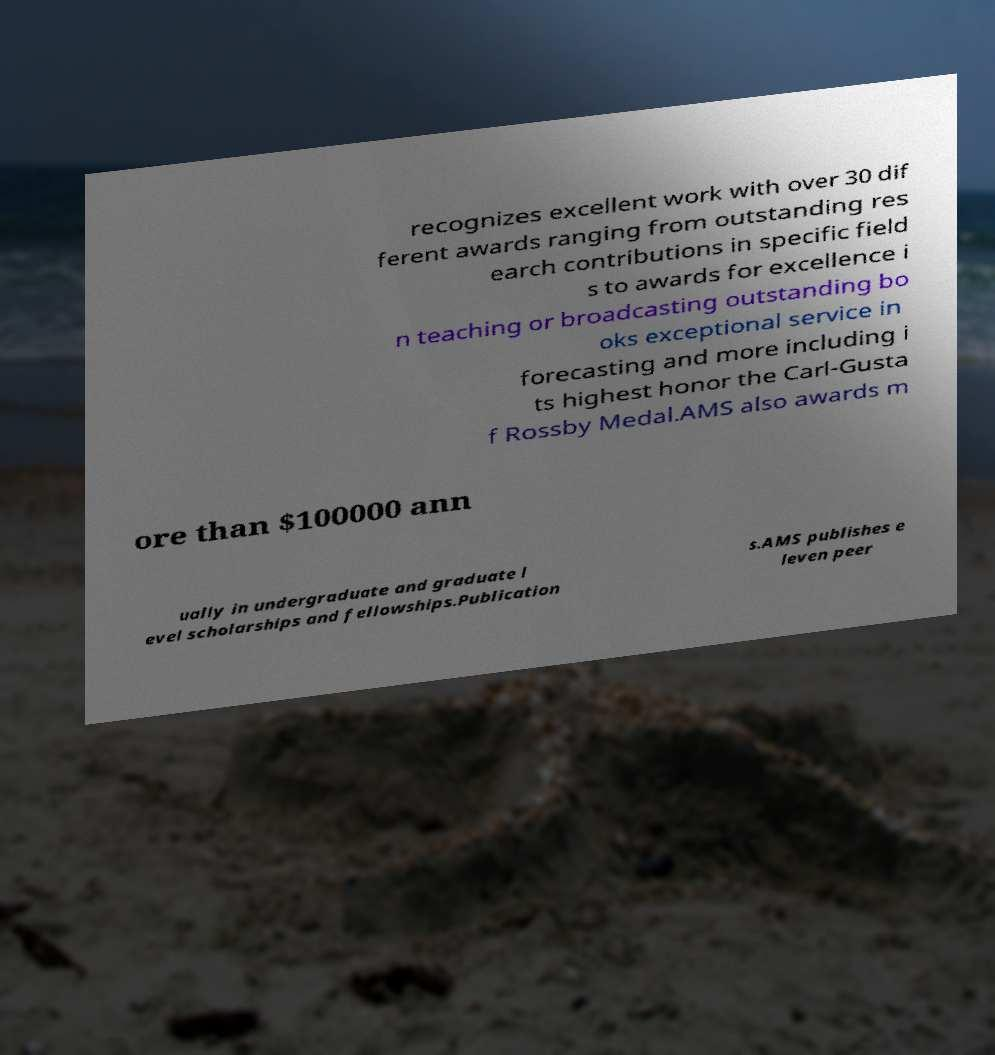For documentation purposes, I need the text within this image transcribed. Could you provide that? recognizes excellent work with over 30 dif ferent awards ranging from outstanding res earch contributions in specific field s to awards for excellence i n teaching or broadcasting outstanding bo oks exceptional service in forecasting and more including i ts highest honor the Carl-Gusta f Rossby Medal.AMS also awards m ore than $100000 ann ually in undergraduate and graduate l evel scholarships and fellowships.Publication s.AMS publishes e leven peer 